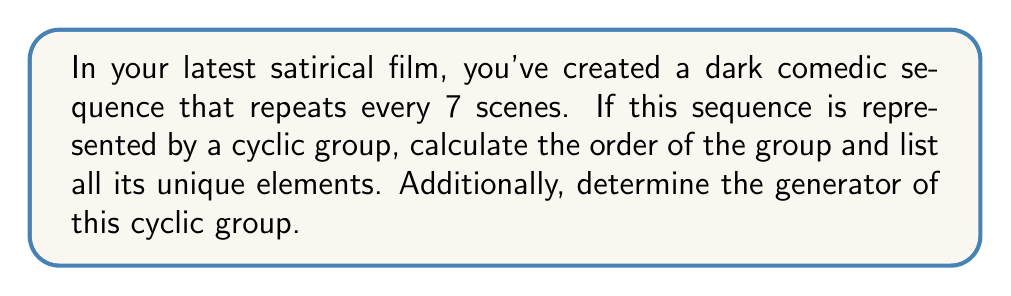Solve this math problem. To solve this problem, we need to understand the concept of cyclic groups and how they relate to the given scenario:

1) A cyclic group is a group that can be generated by a single element, called the generator.

2) In this case, the repeating sequence of 7 scenes can be represented as a cyclic group of order 7.

3) The order of a group is the number of elements in the group. Here, it's 7 because the sequence repeats after 7 scenes.

4) The elements of the group can be represented as:
   $\{e, a, a^2, a^3, a^4, a^5, a^6\}$
   where $e$ is the identity element (no change in scene) and $a$ represents moving to the next scene.

5) $a^7 = e$ because after 7 scenes, we return to the starting point.

6) The generator of this group is $a$, as all elements can be generated by repeated application of $a$.

7) To verify, let's see how each element is generated:
   $a^1 = a$
   $a^2 = aa$
   $a^3 = aaa$
   $a^4 = aaaa$
   $a^5 = aaaaa$
   $a^6 = aaaaaa$
   $a^7 = aaaaaaa = e$ (back to the start)

Thus, $a$ generates all elements of the group.
Answer: The order of the cyclic group is 7. The unique elements are $\{e, a, a^2, a^3, a^4, a^5, a^6\}$. The generator of the group is $a$. 